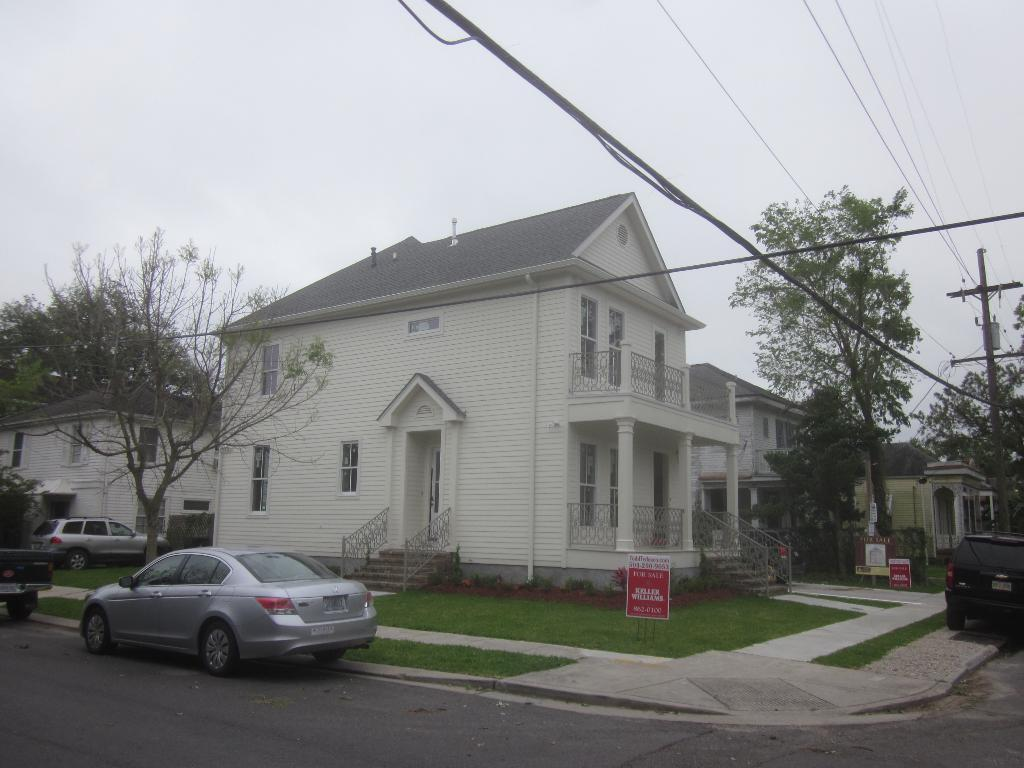What type of structures can be seen in the image? There are buildings in the image. What else can be seen moving in the image? There are vehicles in the image. What type of vegetation is present in the image? There is grass in the image. What type of information might be conveyed by the sign boards in the image? The sign boards in the image might convey information about directions, advertisements, or warnings. What can be seen in the background of the image? In the background of the image, there are trees, cables, and a pole. Can you see a flock of birds flying over the hill in the image? There is no hill or flock of birds present in the image. 